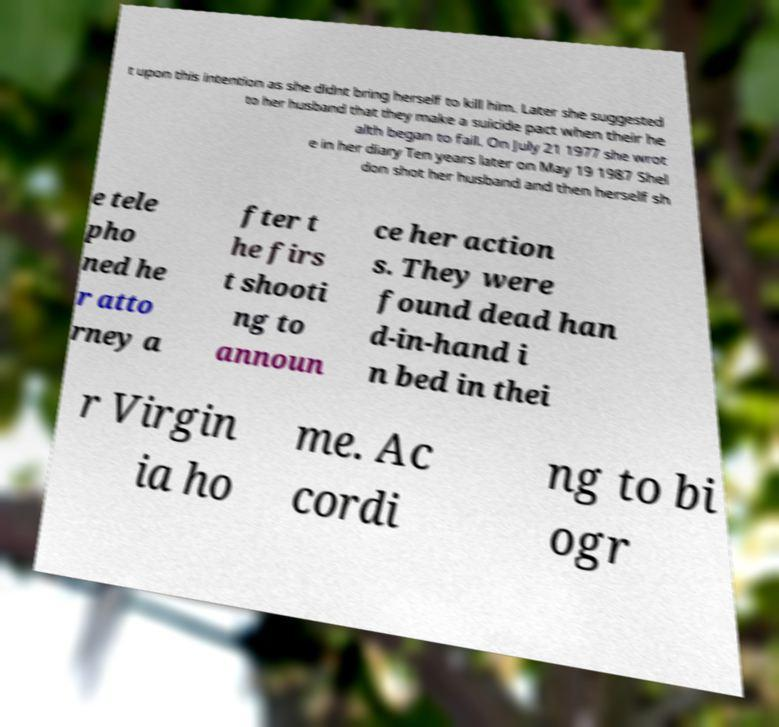There's text embedded in this image that I need extracted. Can you transcribe it verbatim? t upon this intention as she didnt bring herself to kill him. Later she suggested to her husband that they make a suicide pact when their he alth began to fail. On July 21 1977 she wrot e in her diary Ten years later on May 19 1987 Shel don shot her husband and then herself sh e tele pho ned he r atto rney a fter t he firs t shooti ng to announ ce her action s. They were found dead han d-in-hand i n bed in thei r Virgin ia ho me. Ac cordi ng to bi ogr 